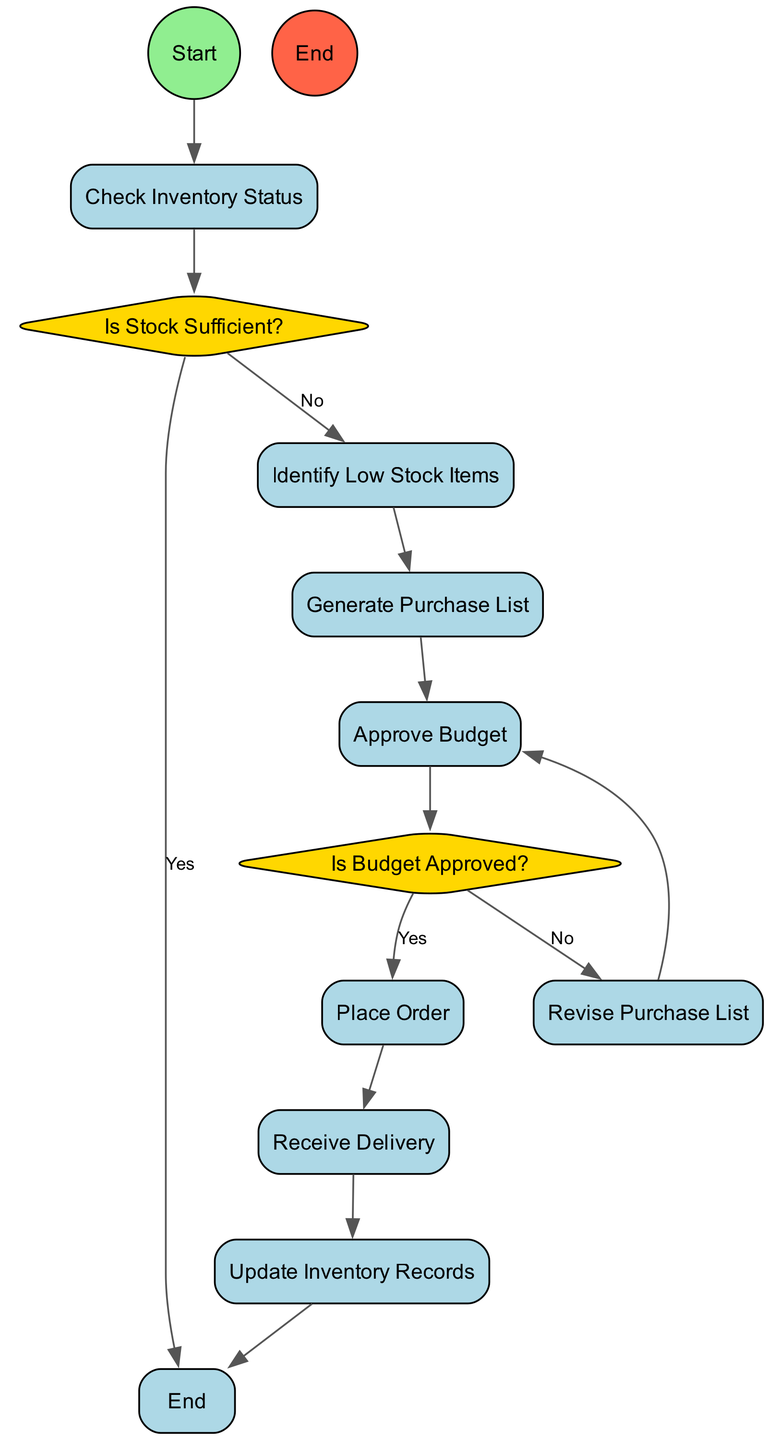What is the starting action in the diagram? The diagram begins with the action noted as "Check Inventory Status," which is the first step that initiates the process of managing cleaning supplies.
Answer: Check Inventory Status How many decision nodes are present in the diagram? The diagram contains two decision nodes: "Is Stock Sufficient?" and "Is Budget Approved?" which are essential checkpoints in the process.
Answer: 2 What action follows "Identify Low Stock Items"? The action that follows "Identify Low Stock Items" in the flow is "Generate Purchase List," indicating the next step after identifying items that need replenishing.
Answer: Generate Purchase List What happens if the budget is not approved? If the budget is not approved, the next action is "Revise Purchase List," where adjustments are made to the purchase list in accordance with the budget constraints.
Answer: Revise Purchase List What is the final action before the process ends? The last action before reaching the end of the process is "Update Inventory Records," which is essential for maintaining accurate inventory data after receiving new supplies.
Answer: Update Inventory Records What is the condition checked after "Approve Budget"? After "Approve Budget," the condition checked is "Is Budget Approved?" which determines the next steps based on whether the budget has been sanctioned or not.
Answer: Is Budget Approved? 